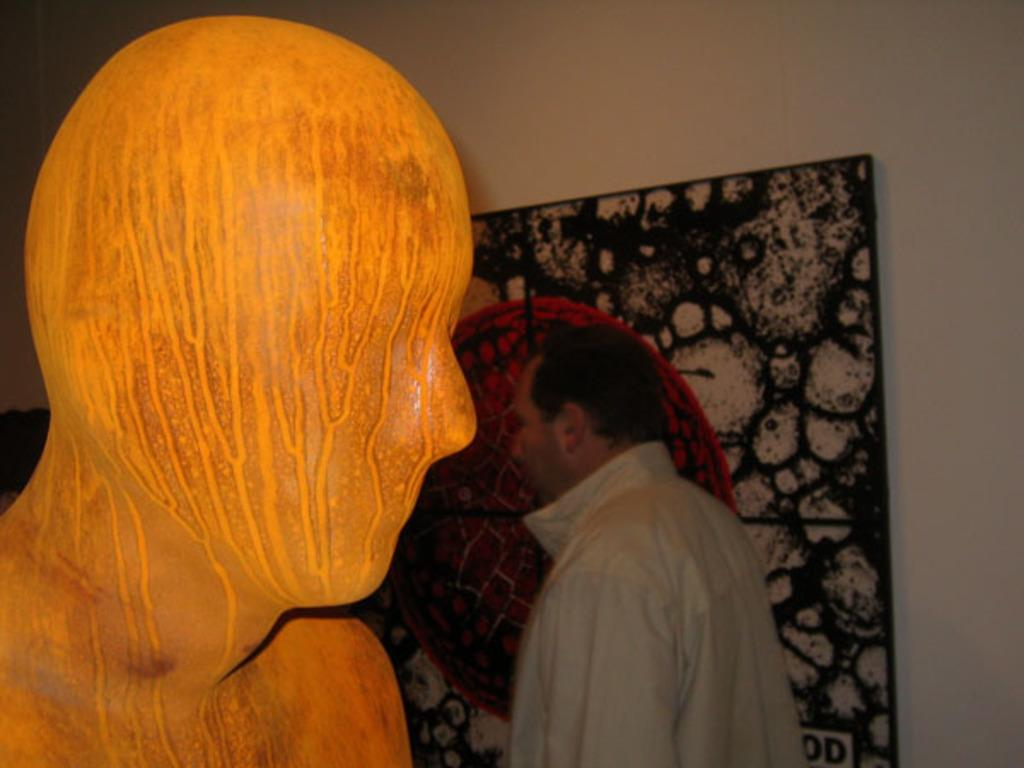What color is the prominent object in the image? There is an orange-colored object in the image. Can you describe the man in the background of the image? The man in the background is wearing a white shirt. What other color can be seen in the background of the image? There is a black-colored object in the background of the image. What size is the house in the image? There is no house present in the image. 